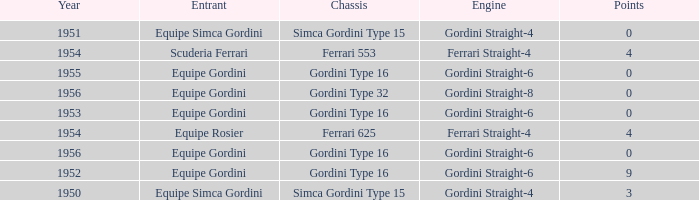What chassis has smaller than 9 points by Equipe Rosier? Ferrari 625. 